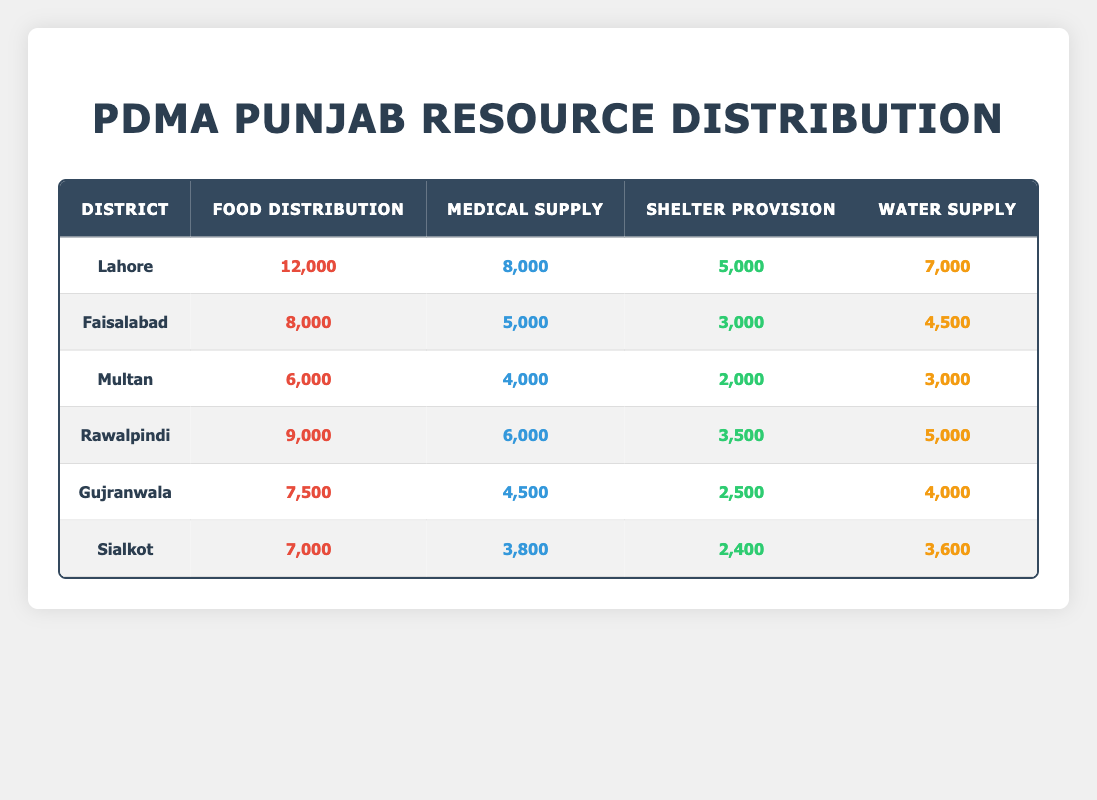What is the total amount of food distributed across all districts? To find the total food distribution, we will sum the food distribution values of all districts: Lahore (12000) + Faisalabad (8000) + Multan (6000) + Rawalpindi (9000) + Gujranwala (7500) + Sialkot (7000). This gives us a total of 12000 + 8000 + 6000 + 9000 + 7500 + 7000 =  49500.
Answer: 49500 Which district received the highest medical supply? We will compare the medical supply values for each district: Lahore (8000), Faisalabad (5000), Multan (4000), Rawalpindi (6000), Gujranwala (4500), Sialkot (3800). The highest value is 8000 from Lahore.
Answer: Lahore Is the water supply greater in Faisalabad than in Multan? The water supply for Faisalabad is 4500, whereas for Multan it is 3000. Since 4500 is greater than 3000, the statement is true.
Answer: Yes What is the average shelter provision across all districts? To find the average shelter provision, first, we sum the shelter provision for all districts: Lahore (5000) + Faisalabad (3000) + Multan (2000) + Rawalpindi (3500) + Gujranwala (2500) + Sialkot (2400) = 18400. There are 6 districts, so the average is 18400 / 6 = 3066.67.
Answer: 3066.67 Which district has the lowest overall resource allocation when considering all four categories combined? To determine this, we can calculate the total resource allocation for each district: Lahore (12000 + 8000 + 5000 + 7000 = 32000), Faisalabad (8000 + 5000 + 3000 + 4500 = 20500), Multan (6000 + 4000 + 2000 + 3000 = 15000), Rawalpindi (9000 + 6000 + 3500 + 5000 = 23500), Gujranwala (7500 + 4500 + 2500 + 4000 = 18500), Sialkot (7000 + 3800 + 2400 + 3600 = 16800). Multan has the lowest total of 15000.
Answer: Multan Is the total medical supply provided to Lahore more than the total water supply provided to Sialkot? We compare Lahore's medical supply (8000) with Sialkot's water supply (3600). Since 8000 is greater than 3600, the statement is true.
Answer: Yes 